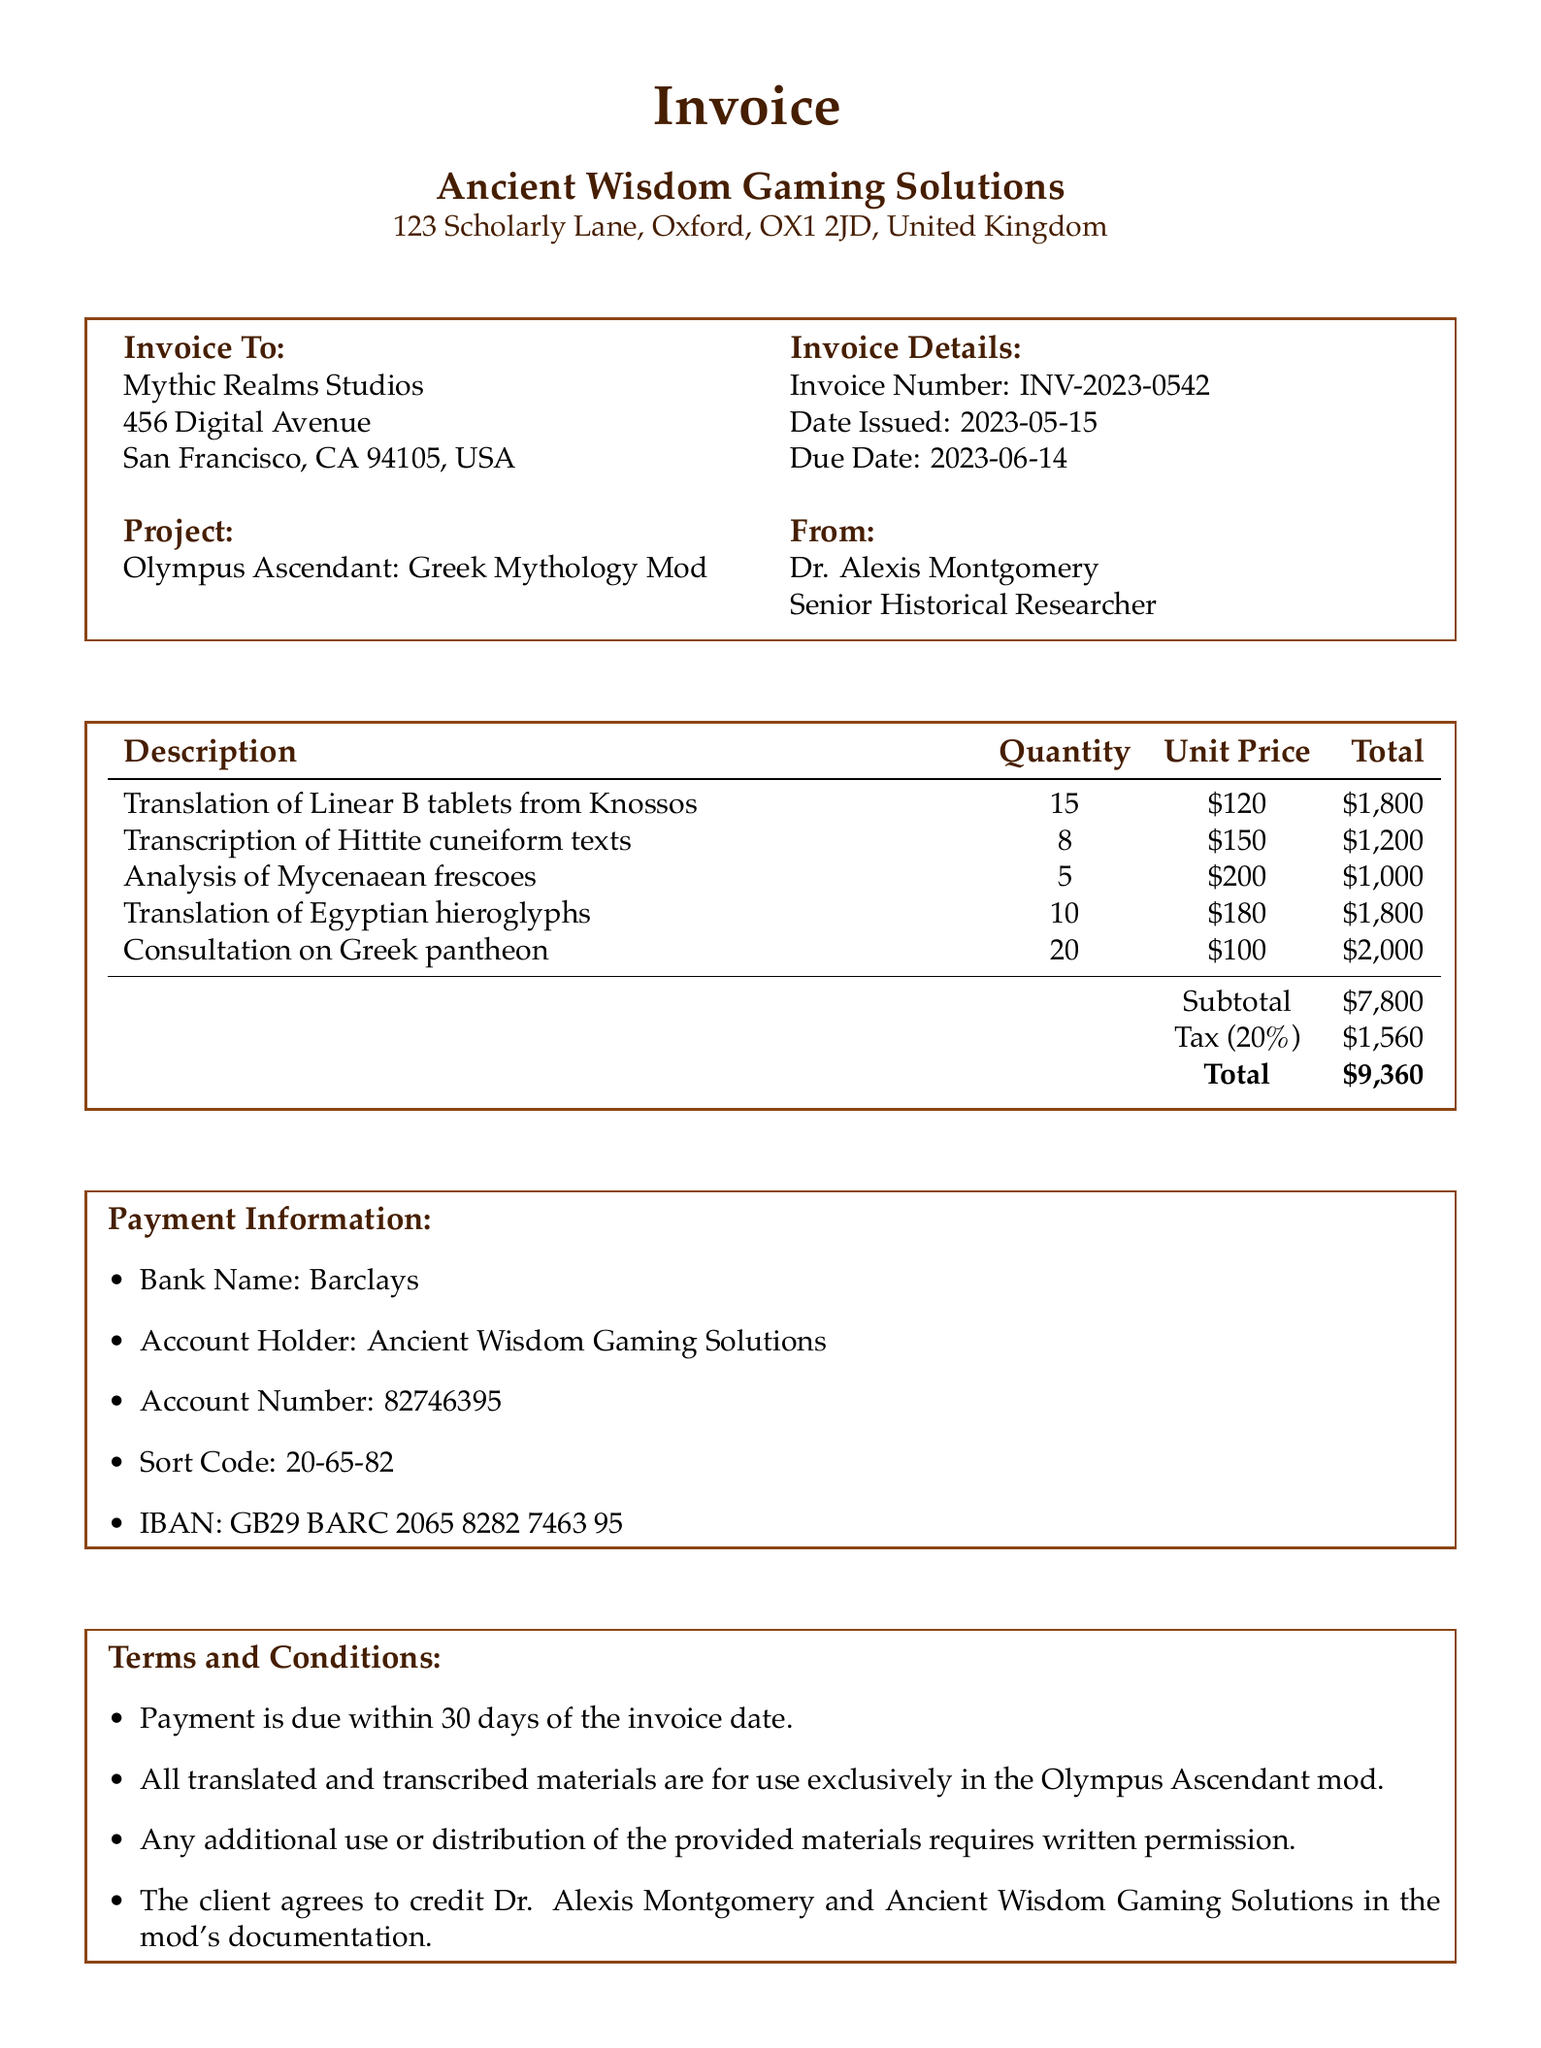what is the invoice number? The invoice number is listed in the invoice details section.
Answer: INV-2023-0542 who is the senior historical researcher? The name of the senior historical researcher is provided in the document under researcher details.
Answer: Dr. Alexis Montgomery what is the due date for this invoice? The due date is specified in the invoice details section.
Answer: 2023-06-14 how many Linear B tablets were translated? The quantity of Linear B tablets is indicated in the services section of the document.
Answer: 15 what is the subtotal amount before tax? The subtotal amount is calculated prior to tax in the additional details section.
Answer: 7800 which client is this invoice addressed to? The client's name is displayed at the beginning of the document.
Answer: Mythic Realms Studios what is the total amount due including tax? The total amount is the final amount after adding tax, found in the additional details section.
Answer: 9360 what is required for additional use of provided materials? The terms and conditions outline the requirements for additional use of the materials.
Answer: Written permission how many services are listed in the invoice? The number of services provided is indicated by the entries in the services section.
Answer: 5 